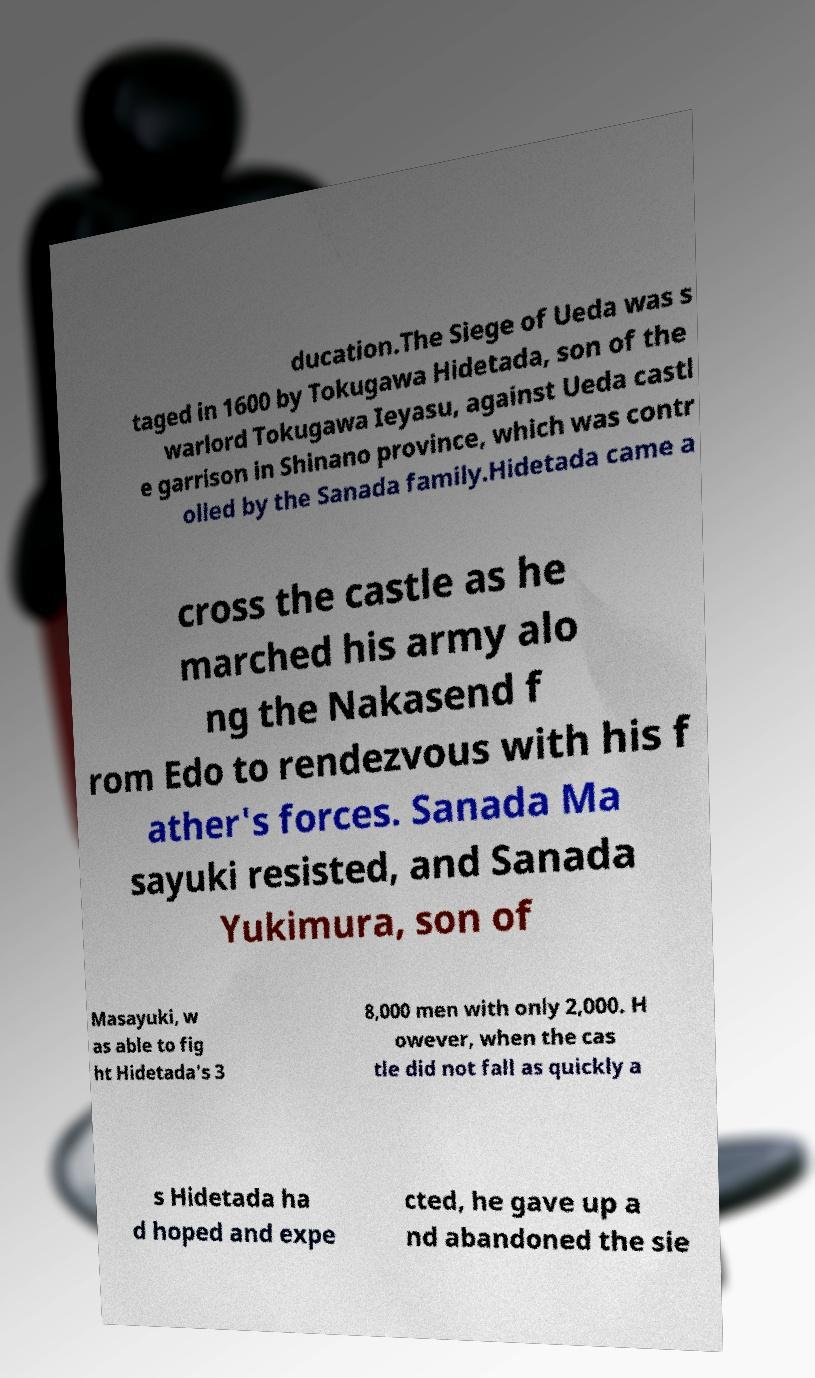Please read and relay the text visible in this image. What does it say? ducation.The Siege of Ueda was s taged in 1600 by Tokugawa Hidetada, son of the warlord Tokugawa Ieyasu, against Ueda castl e garrison in Shinano province, which was contr olled by the Sanada family.Hidetada came a cross the castle as he marched his army alo ng the Nakasend f rom Edo to rendezvous with his f ather's forces. Sanada Ma sayuki resisted, and Sanada Yukimura, son of Masayuki, w as able to fig ht Hidetada's 3 8,000 men with only 2,000. H owever, when the cas tle did not fall as quickly a s Hidetada ha d hoped and expe cted, he gave up a nd abandoned the sie 